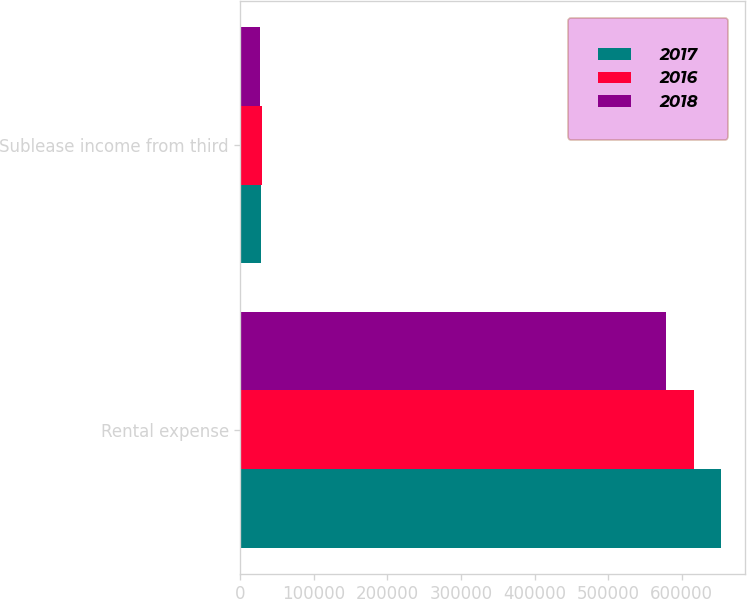<chart> <loc_0><loc_0><loc_500><loc_500><stacked_bar_chart><ecel><fcel>Rental expense<fcel>Sublease income from third<nl><fcel>2017<fcel>653531<fcel>28219<nl><fcel>2016<fcel>617014<fcel>28992<nl><fcel>2018<fcel>578149<fcel>26403<nl></chart> 